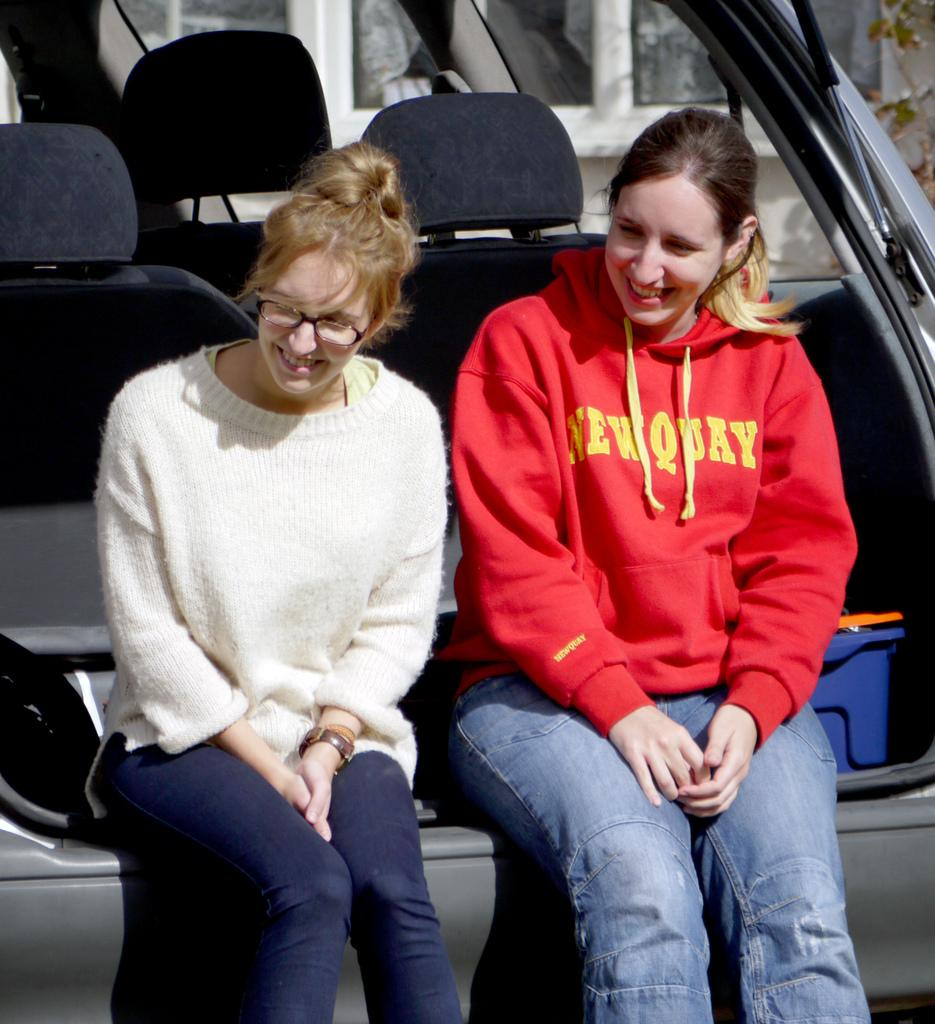How many women are in the image? There are two women in the image. What are the women doing in the image? The women are sitting at the back of a vehicle and smiling. What can be seen through the windows in the image? The presence of a tree suggests that there is a natural setting visible through the windows. What object is present in the image that could be used for carrying items? There is a basket in the image. What type of pen can be seen in the hands of the women in the image? There is no pen visible in the hands of the women in the image. How does the taste of the rainstorm affect the women in the image? There is no rainstorm present in the image, so it cannot affect the women or their taste. 